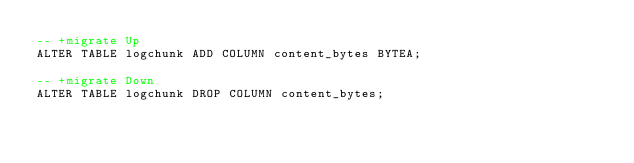Convert code to text. <code><loc_0><loc_0><loc_500><loc_500><_SQL_>-- +migrate Up
ALTER TABLE logchunk ADD COLUMN content_bytes BYTEA;

-- +migrate Down
ALTER TABLE logchunk DROP COLUMN content_bytes;
</code> 